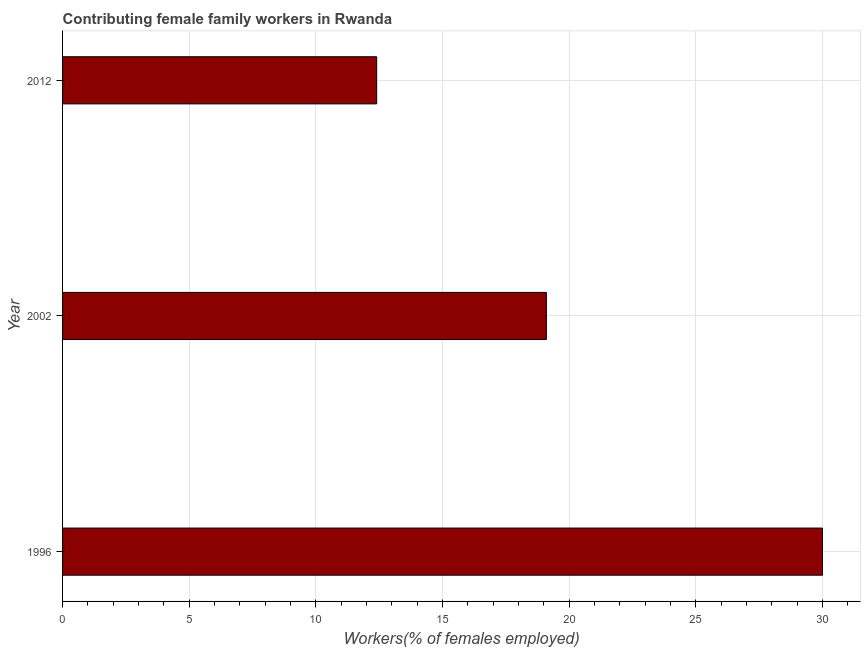Does the graph contain any zero values?
Give a very brief answer. No. What is the title of the graph?
Make the answer very short. Contributing female family workers in Rwanda. What is the label or title of the X-axis?
Give a very brief answer. Workers(% of females employed). Across all years, what is the maximum contributing female family workers?
Keep it short and to the point. 30. Across all years, what is the minimum contributing female family workers?
Your answer should be very brief. 12.4. In which year was the contributing female family workers maximum?
Give a very brief answer. 1996. What is the sum of the contributing female family workers?
Provide a short and direct response. 61.5. What is the difference between the contributing female family workers in 1996 and 2012?
Keep it short and to the point. 17.6. What is the average contributing female family workers per year?
Provide a succinct answer. 20.5. What is the median contributing female family workers?
Keep it short and to the point. 19.1. Do a majority of the years between 2002 and 2012 (inclusive) have contributing female family workers greater than 14 %?
Your answer should be very brief. No. What is the ratio of the contributing female family workers in 2002 to that in 2012?
Offer a very short reply. 1.54. Is the sum of the contributing female family workers in 2002 and 2012 greater than the maximum contributing female family workers across all years?
Provide a succinct answer. Yes. What is the difference between the highest and the lowest contributing female family workers?
Provide a succinct answer. 17.6. In how many years, is the contributing female family workers greater than the average contributing female family workers taken over all years?
Give a very brief answer. 1. What is the difference between two consecutive major ticks on the X-axis?
Your response must be concise. 5. What is the Workers(% of females employed) in 1996?
Make the answer very short. 30. What is the Workers(% of females employed) of 2002?
Offer a very short reply. 19.1. What is the Workers(% of females employed) in 2012?
Provide a short and direct response. 12.4. What is the difference between the Workers(% of females employed) in 1996 and 2002?
Provide a succinct answer. 10.9. What is the difference between the Workers(% of females employed) in 1996 and 2012?
Your answer should be compact. 17.6. What is the difference between the Workers(% of females employed) in 2002 and 2012?
Give a very brief answer. 6.7. What is the ratio of the Workers(% of females employed) in 1996 to that in 2002?
Your answer should be compact. 1.57. What is the ratio of the Workers(% of females employed) in 1996 to that in 2012?
Offer a very short reply. 2.42. What is the ratio of the Workers(% of females employed) in 2002 to that in 2012?
Offer a terse response. 1.54. 